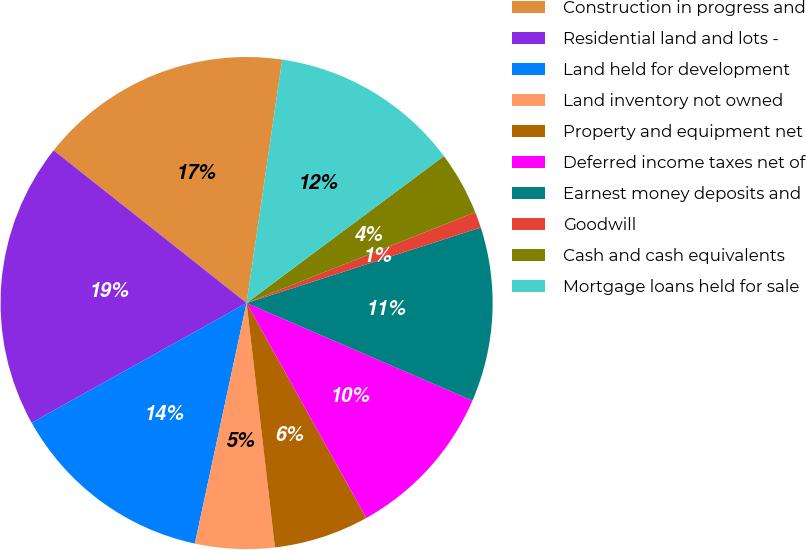<chart> <loc_0><loc_0><loc_500><loc_500><pie_chart><fcel>Construction in progress and<fcel>Residential land and lots -<fcel>Land held for development<fcel>Land inventory not owned<fcel>Property and equipment net<fcel>Deferred income taxes net of<fcel>Earnest money deposits and<fcel>Goodwill<fcel>Cash and cash equivalents<fcel>Mortgage loans held for sale<nl><fcel>16.66%<fcel>18.74%<fcel>13.54%<fcel>5.21%<fcel>6.25%<fcel>10.42%<fcel>11.46%<fcel>1.05%<fcel>4.17%<fcel>12.5%<nl></chart> 